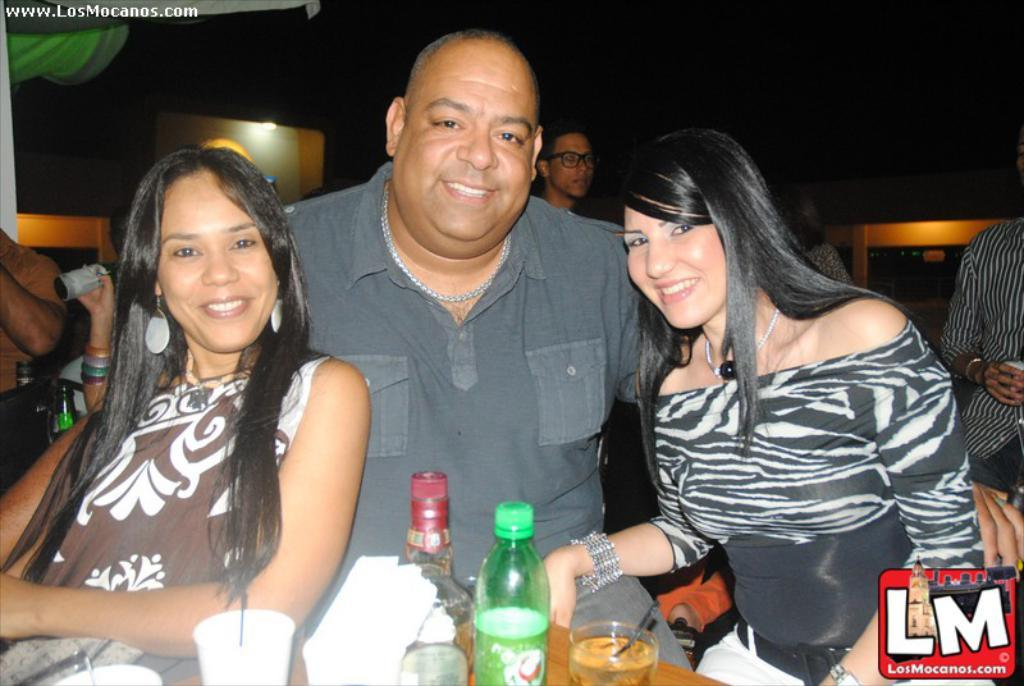What is the color of the background in the image? The background of the image is dark. How many people are in the image? There are three persons in the image. What are the people doing in the image? The persons are sitting on chairs and smiling. What objects can be seen on the table in the image? There are bottles, drinking glasses, and tissue papers on the table. Can you tell me what type of cart is being used by the persons in the image? There is no cart present in the image; the persons are sitting on chairs. What part of the brain can be seen in the image? There is no brain visible in the image; it features three smiling people sitting on chairs. 